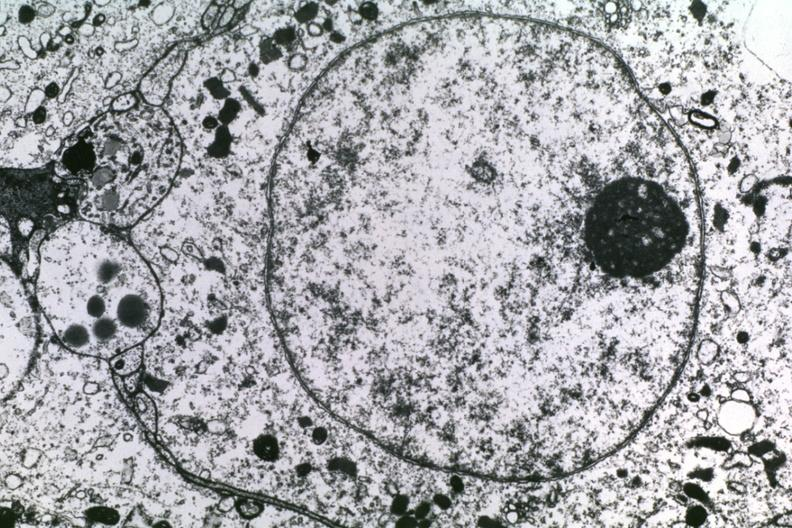what is present?
Answer the question using a single word or phrase. Subependymal giant cell astrocytoma 